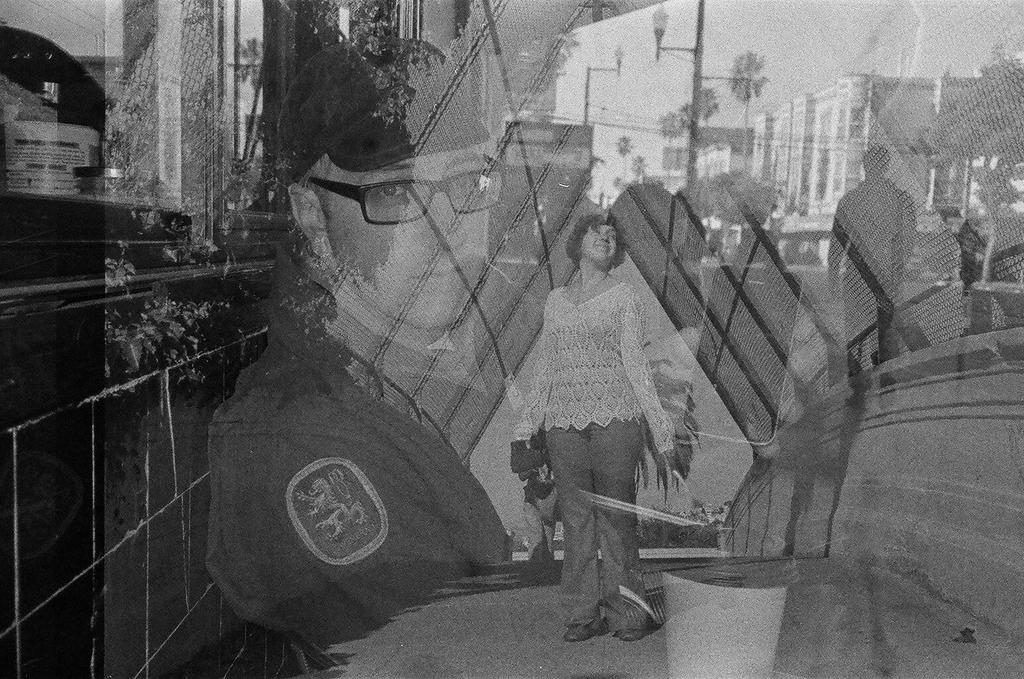Who or what is present in the image? There are people in the image. What structures can be seen in the image? There are poles and buildings in the image. What type of natural environment is visible in the image? There are many trees in the image. What can be seen in the background of the image? The sky is visible in the background of the image. What is the color scheme of the image? The image is black and white. What type of orange powder can be seen on the ground in the image? There is no orange powder present in the image; it is a black and white image with no visible powder. 